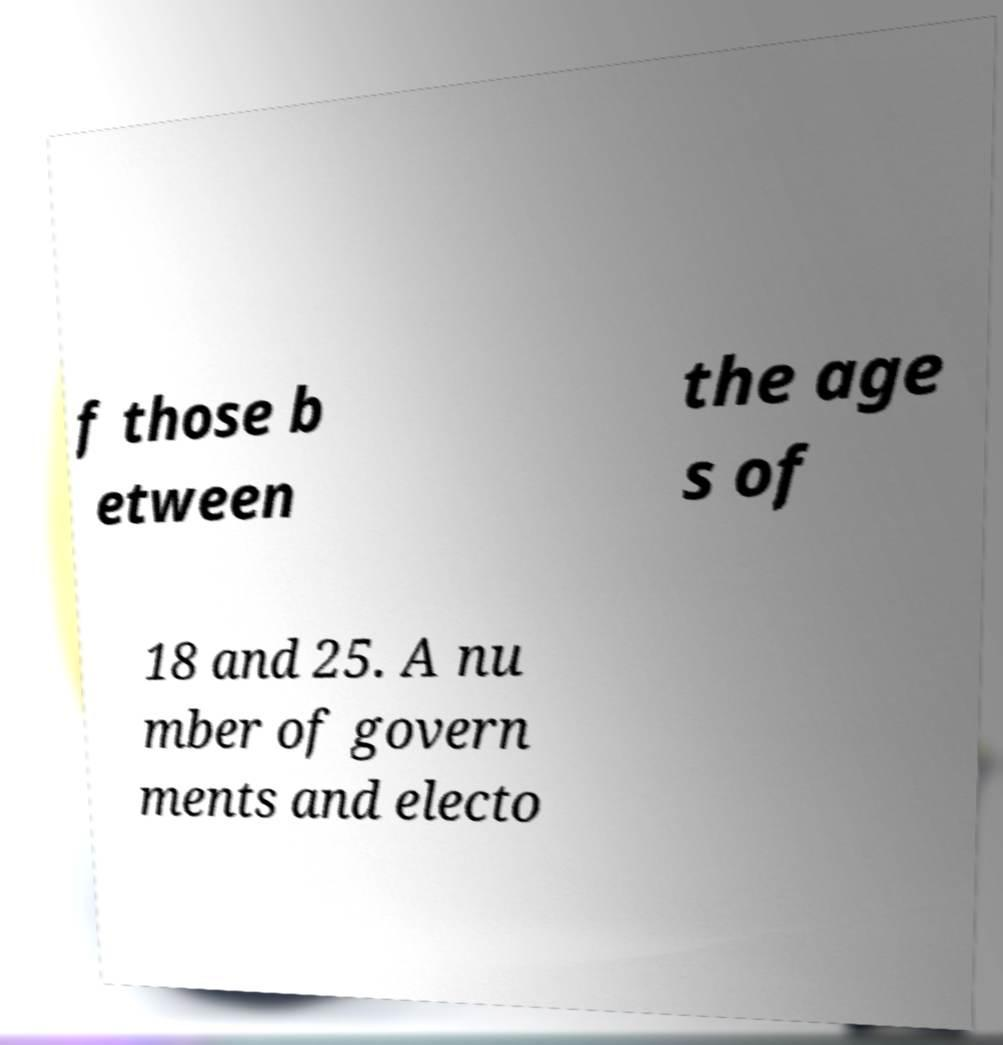Could you extract and type out the text from this image? f those b etween the age s of 18 and 25. A nu mber of govern ments and electo 